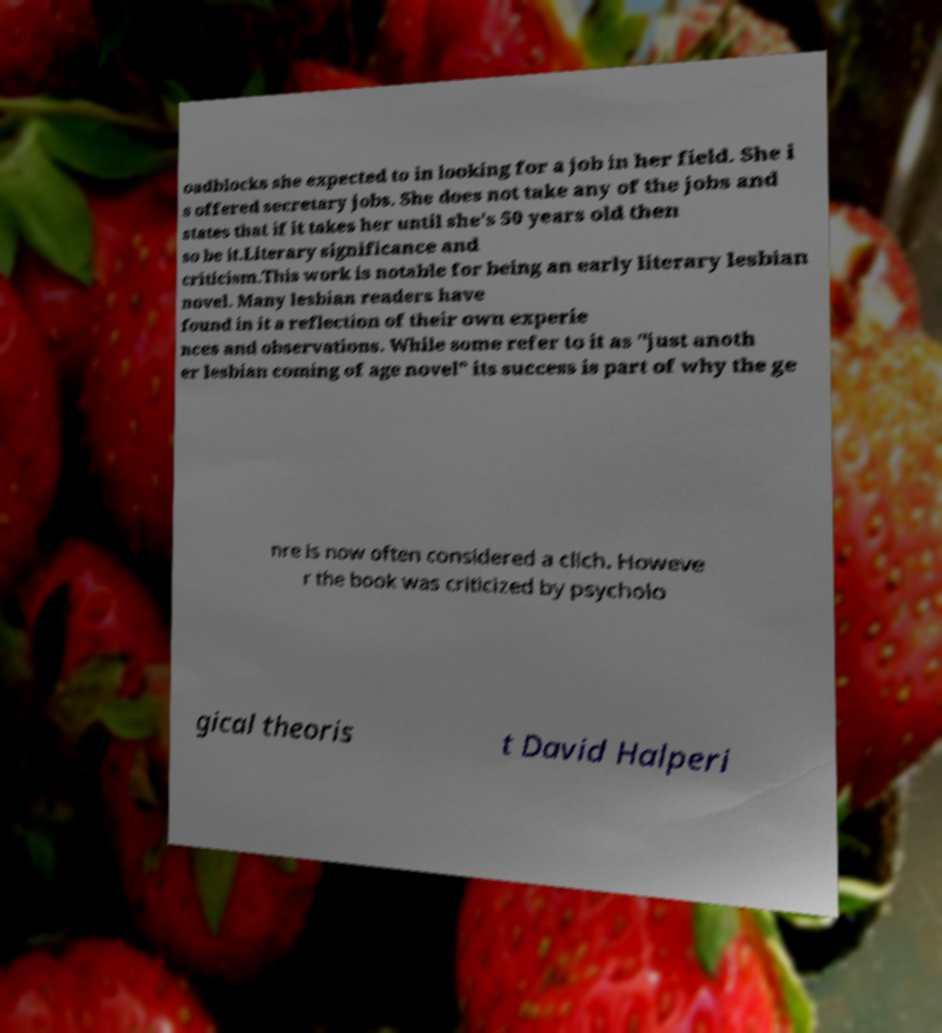Could you assist in decoding the text presented in this image and type it out clearly? oadblocks she expected to in looking for a job in her field. She i s offered secretary jobs. She does not take any of the jobs and states that if it takes her until she's 50 years old then so be it.Literary significance and criticism.This work is notable for being an early literary lesbian novel. Many lesbian readers have found in it a reflection of their own experie nces and observations. While some refer to it as "just anoth er lesbian coming of age novel" its success is part of why the ge nre is now often considered a clich. Howeve r the book was criticized by psycholo gical theoris t David Halperi 